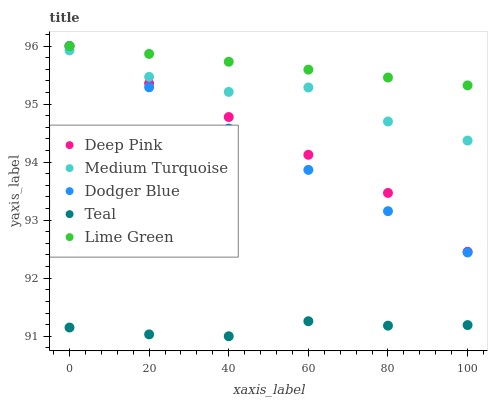Does Teal have the minimum area under the curve?
Answer yes or no. Yes. Does Lime Green have the maximum area under the curve?
Answer yes or no. Yes. Does Deep Pink have the minimum area under the curve?
Answer yes or no. No. Does Deep Pink have the maximum area under the curve?
Answer yes or no. No. Is Dodger Blue the smoothest?
Answer yes or no. Yes. Is Medium Turquoise the roughest?
Answer yes or no. Yes. Is Deep Pink the smoothest?
Answer yes or no. No. Is Deep Pink the roughest?
Answer yes or no. No. Does Teal have the lowest value?
Answer yes or no. Yes. Does Deep Pink have the lowest value?
Answer yes or no. No. Does Dodger Blue have the highest value?
Answer yes or no. Yes. Does Teal have the highest value?
Answer yes or no. No. Is Teal less than Lime Green?
Answer yes or no. Yes. Is Lime Green greater than Teal?
Answer yes or no. Yes. Does Medium Turquoise intersect Deep Pink?
Answer yes or no. Yes. Is Medium Turquoise less than Deep Pink?
Answer yes or no. No. Is Medium Turquoise greater than Deep Pink?
Answer yes or no. No. Does Teal intersect Lime Green?
Answer yes or no. No. 